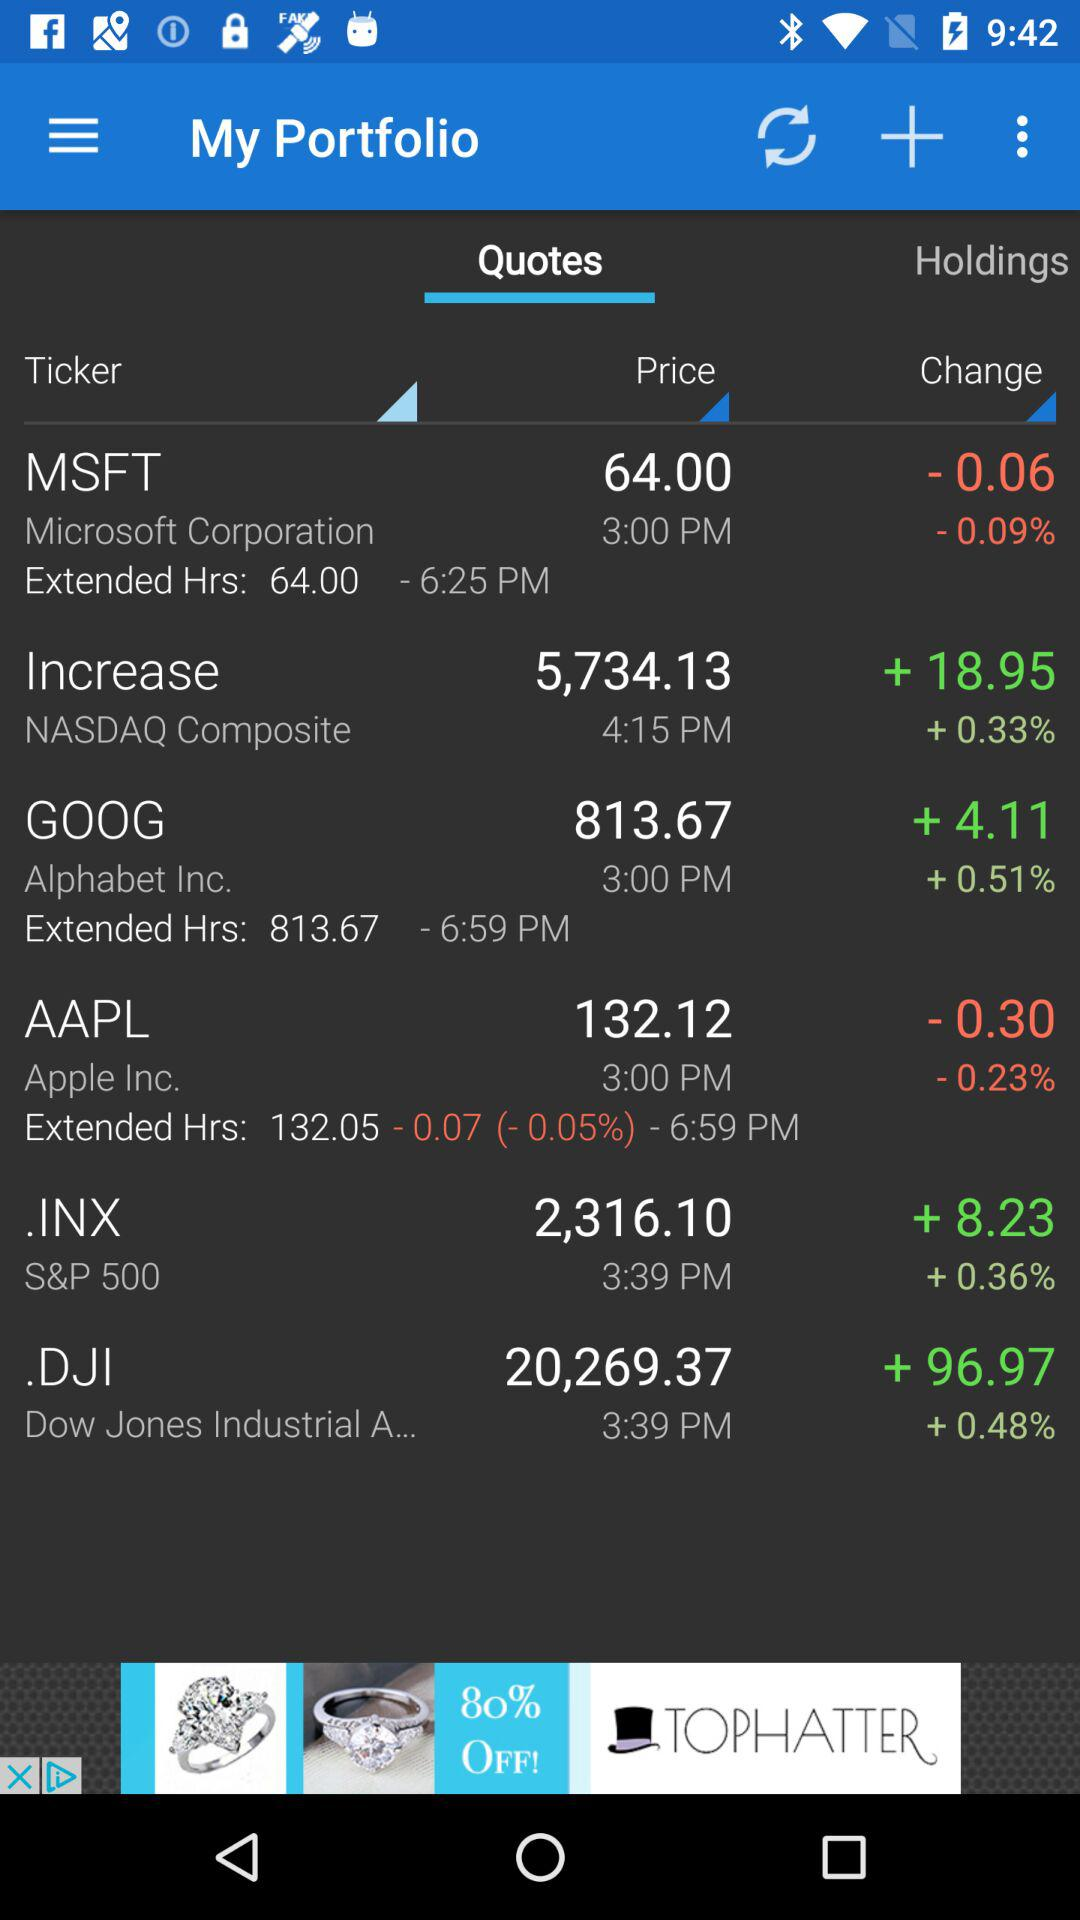What is the percentage change of the price of AAPL?
Answer the question using a single word or phrase. -0.23% 